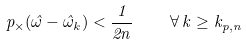<formula> <loc_0><loc_0><loc_500><loc_500>\ p _ { \times } ( \hat { \omega } - \hat { \omega } _ { k } ) < \frac { 1 } { 2 n } \quad \forall \, k \geq k _ { p , n }</formula> 